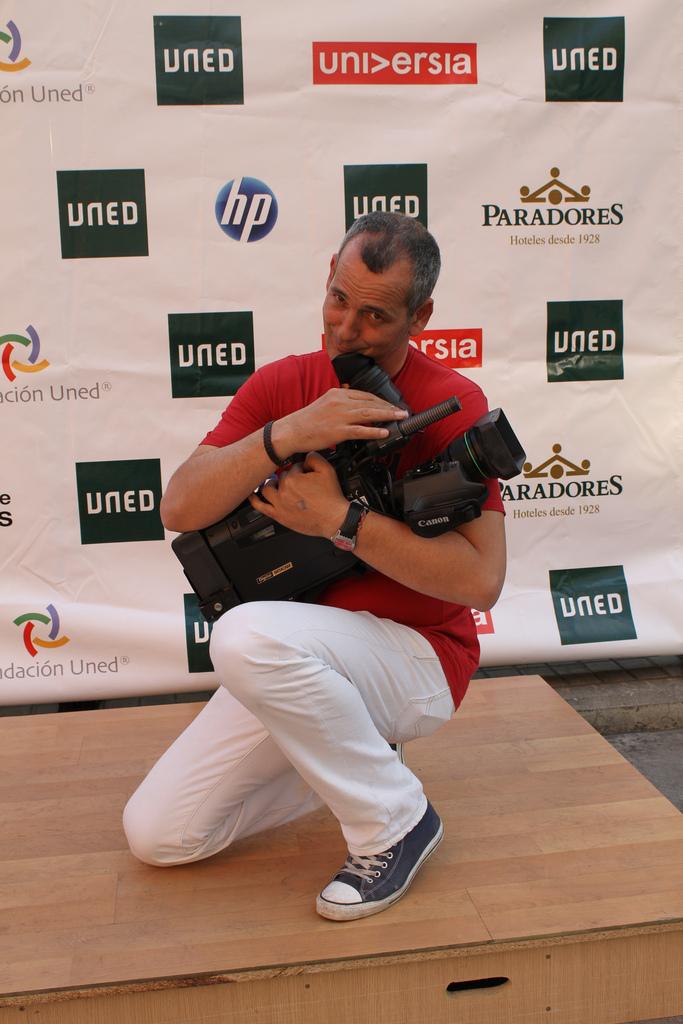What is in his arms?
Your response must be concise. Answering does not require reading text in the image. 